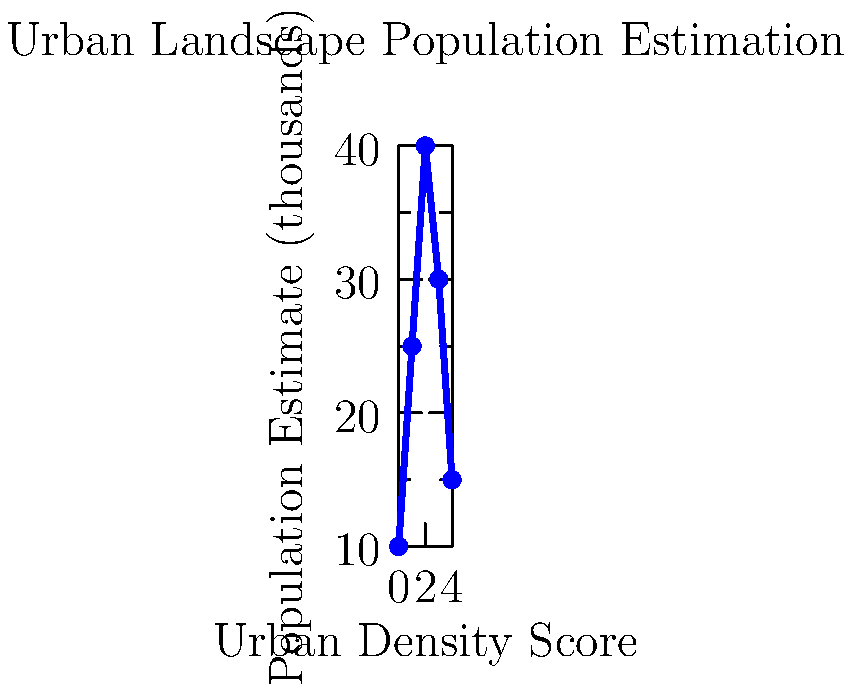Based on the graph showing the relationship between urban density scores and population estimates, what population would you estimate for an area with an urban density score of 2.5? To estimate the population for an urban density score of 2.5, we need to follow these steps:

1. Observe that the graph shows a non-linear relationship between urban density scores and population estimates.

2. Identify the two closest known data points:
   - At score 2, the population is approximately 40,000
   - At score 3, the population is approximately 30,000

3. Calculate the midpoint between these two values:
   $\frac{40,000 + 30,000}{2} = 35,000$

4. Consider the trend of the graph:
   - The peak is closer to score 2 than score 3
   - The curve is slightly skewed towards higher populations at lower scores

5. Adjust the estimate slightly upward from the midpoint:
   A reasonable estimate would be around 36,000 to 37,000

6. Round to the nearest thousand for a final estimate.

This method combines interpolation with qualitative assessment of the graph's shape, which is crucial for estimating population demographics from urban landscape images in human rights contexts.
Answer: 37,000 